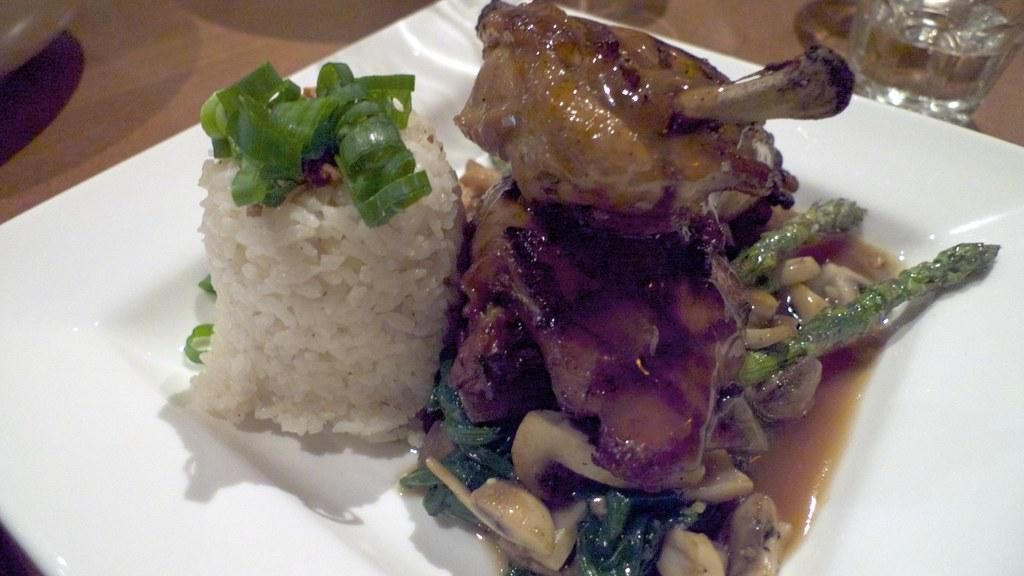What is the main subject of the image? The main subject of the image is food. How is the food presented in the image? The food is on a white plate. Can you describe the appearance of the food? The food is colorful. What other object is present in the image? There is a glass in the image. What is the color of the surface on which the food and glass are placed? The food and glass are on a brown surface. What type of harmony is being played in the background of the image? There is no music or harmony present in the image; it only features food, a white plate, a glass, and a brown surface. 